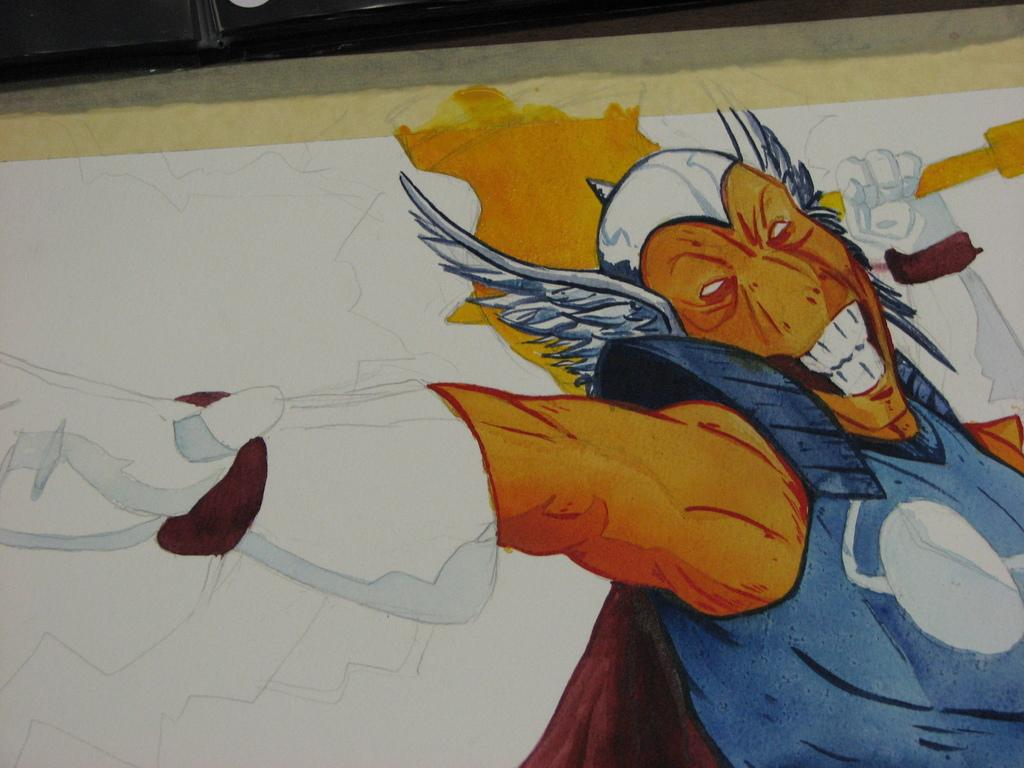What is depicted on the white surface in the image? There is a painting of a person on a white surface. What can be seen below the white surface in the image? There is a floor visible in the image. What type of effect does the heat have on the painting in the image? There is no mention of heat in the image, so it is not possible to determine its effect on the painting. 